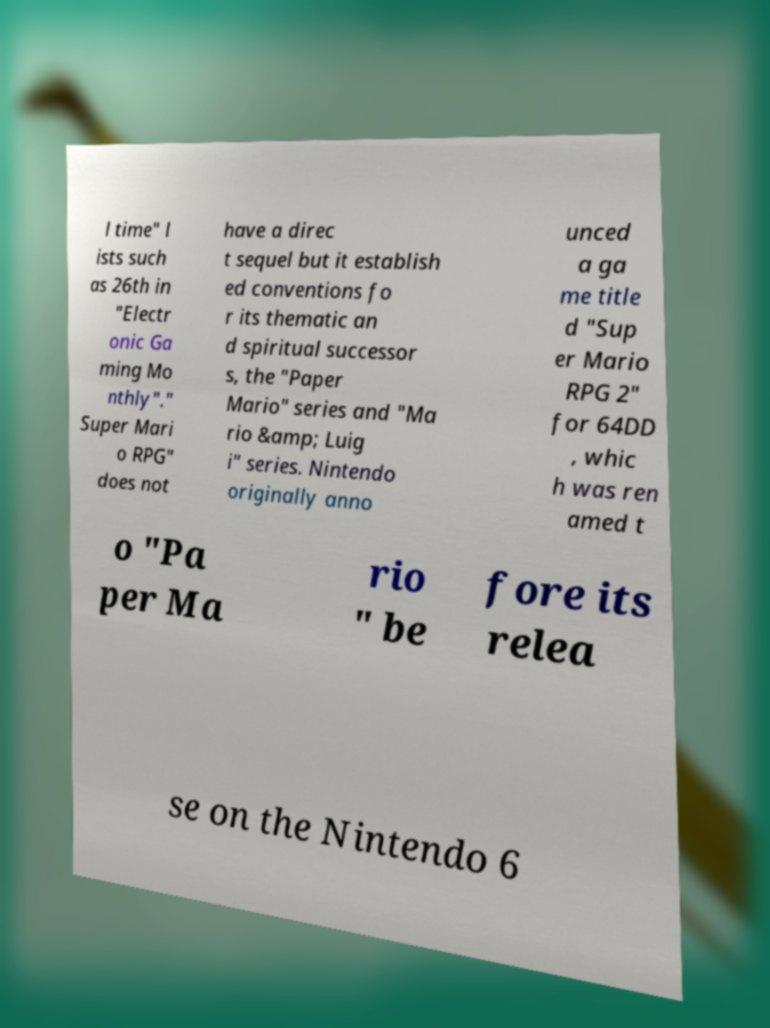Can you read and provide the text displayed in the image?This photo seems to have some interesting text. Can you extract and type it out for me? l time" l ists such as 26th in "Electr onic Ga ming Mo nthly"." Super Mari o RPG" does not have a direc t sequel but it establish ed conventions fo r its thematic an d spiritual successor s, the "Paper Mario" series and "Ma rio &amp; Luig i" series. Nintendo originally anno unced a ga me title d "Sup er Mario RPG 2" for 64DD , whic h was ren amed t o "Pa per Ma rio " be fore its relea se on the Nintendo 6 